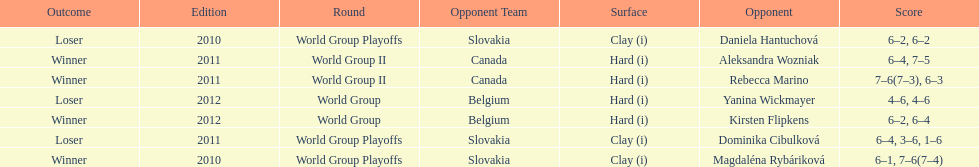Number of games in the match against dominika cibulkova? 3. 